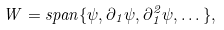<formula> <loc_0><loc_0><loc_500><loc_500>W = s p a n \{ \psi , \partial _ { 1 } \psi , \partial _ { 1 } ^ { 2 } \psi , \dots \} ,</formula> 